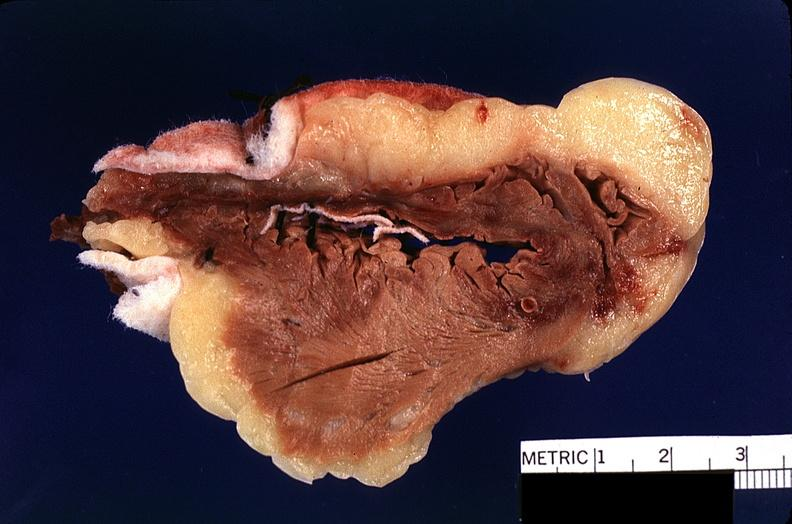where is this?
Answer the question using a single word or phrase. Heart 